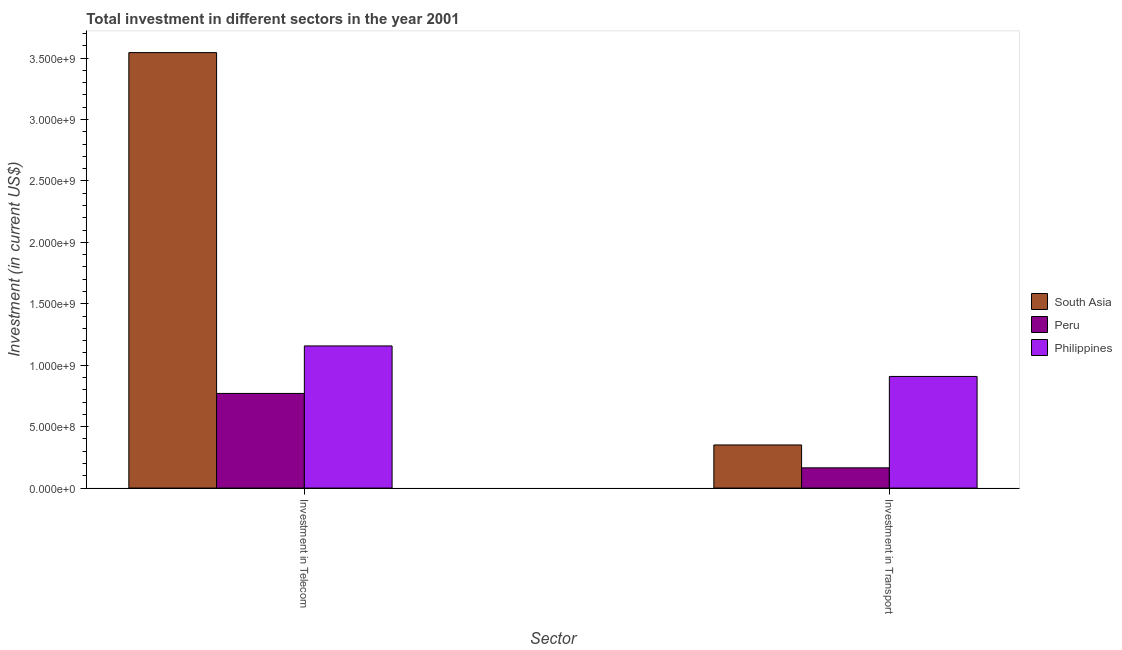How many different coloured bars are there?
Give a very brief answer. 3. How many groups of bars are there?
Your response must be concise. 2. Are the number of bars per tick equal to the number of legend labels?
Make the answer very short. Yes. Are the number of bars on each tick of the X-axis equal?
Your answer should be compact. Yes. How many bars are there on the 1st tick from the left?
Keep it short and to the point. 3. What is the label of the 1st group of bars from the left?
Make the answer very short. Investment in Telecom. What is the investment in transport in Philippines?
Make the answer very short. 9.08e+08. Across all countries, what is the maximum investment in telecom?
Your response must be concise. 3.54e+09. Across all countries, what is the minimum investment in transport?
Your answer should be compact. 1.64e+08. In which country was the investment in telecom minimum?
Ensure brevity in your answer.  Peru. What is the total investment in transport in the graph?
Make the answer very short. 1.42e+09. What is the difference between the investment in telecom in Philippines and that in Peru?
Give a very brief answer. 3.87e+08. What is the difference between the investment in transport in Peru and the investment in telecom in Philippines?
Make the answer very short. -9.92e+08. What is the average investment in telecom per country?
Give a very brief answer. 1.82e+09. What is the difference between the investment in telecom and investment in transport in South Asia?
Provide a succinct answer. 3.19e+09. What is the ratio of the investment in transport in Peru to that in Philippines?
Give a very brief answer. 0.18. Is the investment in telecom in Peru less than that in South Asia?
Keep it short and to the point. Yes. In how many countries, is the investment in transport greater than the average investment in transport taken over all countries?
Give a very brief answer. 1. What does the 3rd bar from the left in Investment in Telecom represents?
Your answer should be compact. Philippines. How many bars are there?
Offer a terse response. 6. How many countries are there in the graph?
Give a very brief answer. 3. What is the difference between two consecutive major ticks on the Y-axis?
Your answer should be very brief. 5.00e+08. Does the graph contain any zero values?
Offer a very short reply. No. Does the graph contain grids?
Make the answer very short. No. Where does the legend appear in the graph?
Provide a short and direct response. Center right. What is the title of the graph?
Make the answer very short. Total investment in different sectors in the year 2001. What is the label or title of the X-axis?
Your response must be concise. Sector. What is the label or title of the Y-axis?
Your answer should be very brief. Investment (in current US$). What is the Investment (in current US$) of South Asia in Investment in Telecom?
Your answer should be very brief. 3.54e+09. What is the Investment (in current US$) of Peru in Investment in Telecom?
Ensure brevity in your answer.  7.70e+08. What is the Investment (in current US$) of Philippines in Investment in Telecom?
Provide a short and direct response. 1.16e+09. What is the Investment (in current US$) of South Asia in Investment in Transport?
Your answer should be very brief. 3.51e+08. What is the Investment (in current US$) of Peru in Investment in Transport?
Provide a succinct answer. 1.64e+08. What is the Investment (in current US$) in Philippines in Investment in Transport?
Your answer should be very brief. 9.08e+08. Across all Sector, what is the maximum Investment (in current US$) in South Asia?
Offer a very short reply. 3.54e+09. Across all Sector, what is the maximum Investment (in current US$) in Peru?
Offer a very short reply. 7.70e+08. Across all Sector, what is the maximum Investment (in current US$) in Philippines?
Offer a very short reply. 1.16e+09. Across all Sector, what is the minimum Investment (in current US$) in South Asia?
Provide a succinct answer. 3.51e+08. Across all Sector, what is the minimum Investment (in current US$) in Peru?
Your response must be concise. 1.64e+08. Across all Sector, what is the minimum Investment (in current US$) in Philippines?
Provide a short and direct response. 9.08e+08. What is the total Investment (in current US$) of South Asia in the graph?
Your response must be concise. 3.90e+09. What is the total Investment (in current US$) of Peru in the graph?
Provide a short and direct response. 9.35e+08. What is the total Investment (in current US$) of Philippines in the graph?
Give a very brief answer. 2.07e+09. What is the difference between the Investment (in current US$) of South Asia in Investment in Telecom and that in Investment in Transport?
Your response must be concise. 3.19e+09. What is the difference between the Investment (in current US$) in Peru in Investment in Telecom and that in Investment in Transport?
Ensure brevity in your answer.  6.06e+08. What is the difference between the Investment (in current US$) of Philippines in Investment in Telecom and that in Investment in Transport?
Offer a terse response. 2.48e+08. What is the difference between the Investment (in current US$) in South Asia in Investment in Telecom and the Investment (in current US$) in Peru in Investment in Transport?
Provide a short and direct response. 3.38e+09. What is the difference between the Investment (in current US$) of South Asia in Investment in Telecom and the Investment (in current US$) of Philippines in Investment in Transport?
Provide a succinct answer. 2.64e+09. What is the difference between the Investment (in current US$) of Peru in Investment in Telecom and the Investment (in current US$) of Philippines in Investment in Transport?
Keep it short and to the point. -1.38e+08. What is the average Investment (in current US$) in South Asia per Sector?
Your answer should be very brief. 1.95e+09. What is the average Investment (in current US$) in Peru per Sector?
Offer a terse response. 4.67e+08. What is the average Investment (in current US$) of Philippines per Sector?
Your answer should be compact. 1.03e+09. What is the difference between the Investment (in current US$) in South Asia and Investment (in current US$) in Peru in Investment in Telecom?
Offer a very short reply. 2.77e+09. What is the difference between the Investment (in current US$) in South Asia and Investment (in current US$) in Philippines in Investment in Telecom?
Keep it short and to the point. 2.39e+09. What is the difference between the Investment (in current US$) of Peru and Investment (in current US$) of Philippines in Investment in Telecom?
Provide a succinct answer. -3.87e+08. What is the difference between the Investment (in current US$) in South Asia and Investment (in current US$) in Peru in Investment in Transport?
Offer a very short reply. 1.86e+08. What is the difference between the Investment (in current US$) in South Asia and Investment (in current US$) in Philippines in Investment in Transport?
Your response must be concise. -5.58e+08. What is the difference between the Investment (in current US$) of Peru and Investment (in current US$) of Philippines in Investment in Transport?
Your response must be concise. -7.44e+08. What is the ratio of the Investment (in current US$) in South Asia in Investment in Telecom to that in Investment in Transport?
Offer a terse response. 10.11. What is the ratio of the Investment (in current US$) in Peru in Investment in Telecom to that in Investment in Transport?
Offer a terse response. 4.68. What is the ratio of the Investment (in current US$) in Philippines in Investment in Telecom to that in Investment in Transport?
Offer a terse response. 1.27. What is the difference between the highest and the second highest Investment (in current US$) in South Asia?
Offer a very short reply. 3.19e+09. What is the difference between the highest and the second highest Investment (in current US$) in Peru?
Your answer should be very brief. 6.06e+08. What is the difference between the highest and the second highest Investment (in current US$) in Philippines?
Offer a terse response. 2.48e+08. What is the difference between the highest and the lowest Investment (in current US$) of South Asia?
Your answer should be very brief. 3.19e+09. What is the difference between the highest and the lowest Investment (in current US$) in Peru?
Offer a terse response. 6.06e+08. What is the difference between the highest and the lowest Investment (in current US$) in Philippines?
Ensure brevity in your answer.  2.48e+08. 